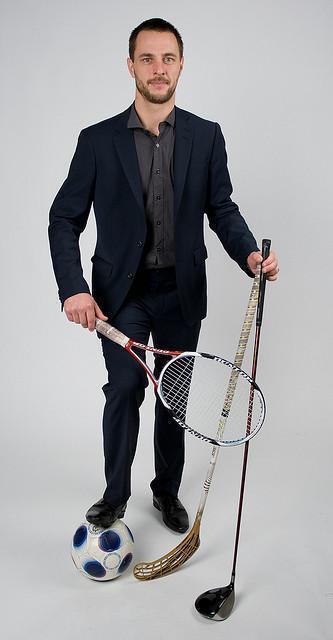How many different types of sports equipment is he holding?
Give a very brief answer. 4. How many elephants are lying down?
Give a very brief answer. 0. 